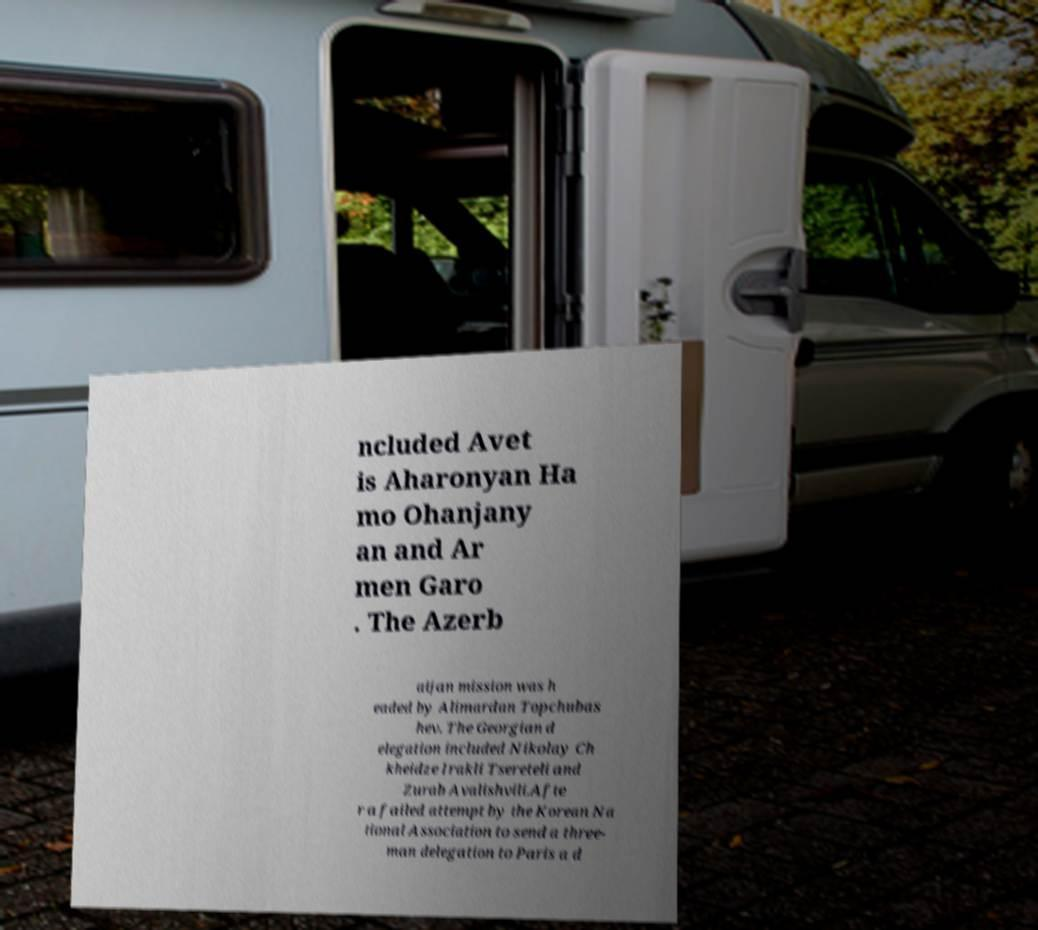What messages or text are displayed in this image? I need them in a readable, typed format. ncluded Avet is Aharonyan Ha mo Ohanjany an and Ar men Garo . The Azerb aijan mission was h eaded by Alimardan Topchubas hev. The Georgian d elegation included Nikolay Ch kheidze Irakli Tsereteli and Zurab Avalishvili.Afte r a failed attempt by the Korean Na tional Association to send a three- man delegation to Paris a d 